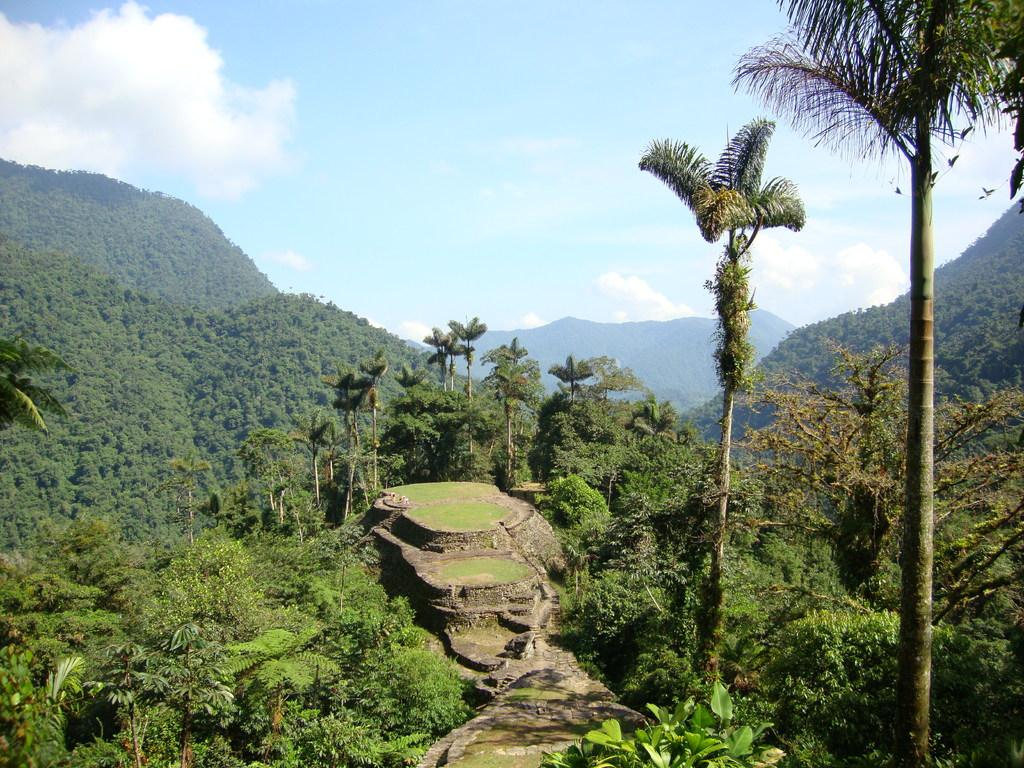What type of vegetation can be seen in the image? There are trees in the image. What type of landscape feature is present in the image? There are hills in the image. What is the color and condition of the sky in the image? The sky is blue and cloudy in the image. Where is the key located in the image? There is no key present in the image. What type of organization is depicted in the image? There is no organization depicted in the image; it features trees, hills, and a blue, cloudy sky. 